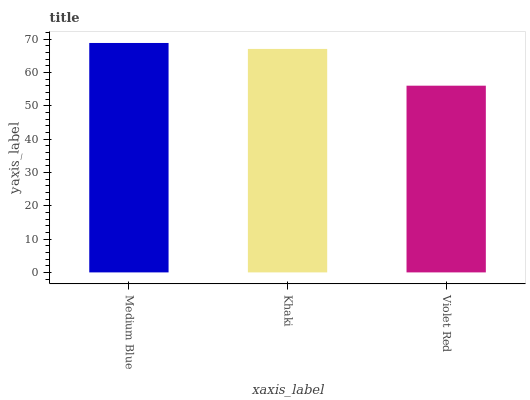Is Khaki the minimum?
Answer yes or no. No. Is Khaki the maximum?
Answer yes or no. No. Is Medium Blue greater than Khaki?
Answer yes or no. Yes. Is Khaki less than Medium Blue?
Answer yes or no. Yes. Is Khaki greater than Medium Blue?
Answer yes or no. No. Is Medium Blue less than Khaki?
Answer yes or no. No. Is Khaki the high median?
Answer yes or no. Yes. Is Khaki the low median?
Answer yes or no. Yes. Is Violet Red the high median?
Answer yes or no. No. Is Violet Red the low median?
Answer yes or no. No. 